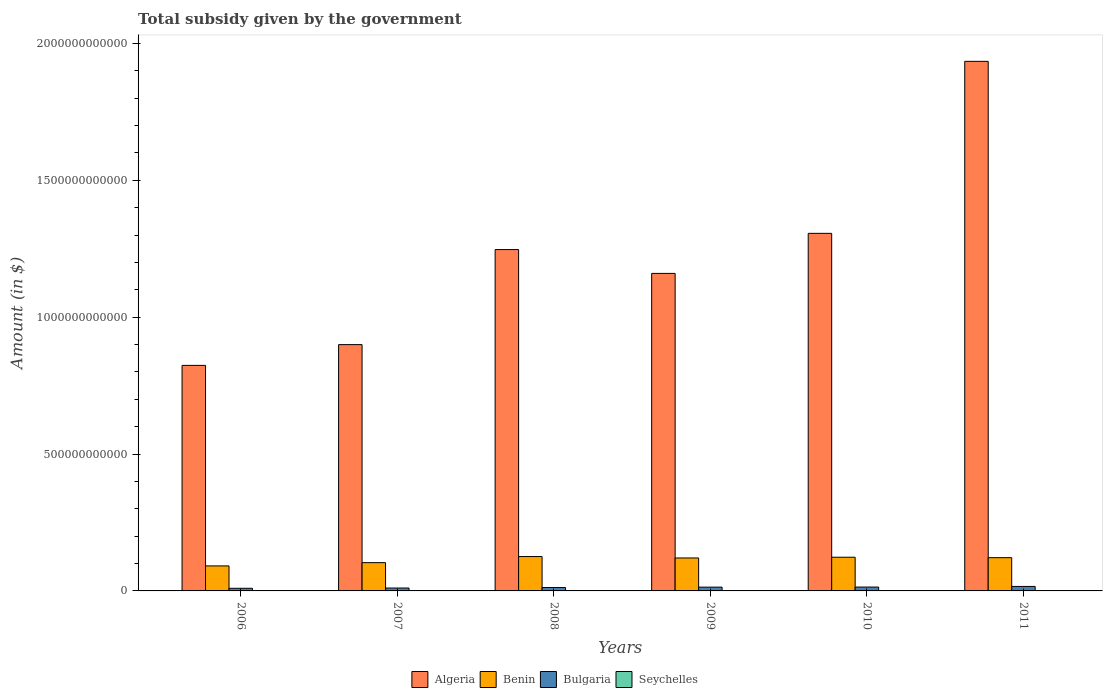How many different coloured bars are there?
Ensure brevity in your answer.  4. How many bars are there on the 1st tick from the left?
Ensure brevity in your answer.  4. How many bars are there on the 3rd tick from the right?
Ensure brevity in your answer.  4. What is the label of the 1st group of bars from the left?
Your response must be concise. 2006. What is the total revenue collected by the government in Seychelles in 2009?
Provide a short and direct response. 5.37e+08. Across all years, what is the maximum total revenue collected by the government in Algeria?
Give a very brief answer. 1.93e+12. Across all years, what is the minimum total revenue collected by the government in Bulgaria?
Offer a terse response. 9.61e+09. In which year was the total revenue collected by the government in Bulgaria maximum?
Your answer should be very brief. 2011. In which year was the total revenue collected by the government in Algeria minimum?
Make the answer very short. 2006. What is the total total revenue collected by the government in Seychelles in the graph?
Your answer should be very brief. 3.62e+09. What is the difference between the total revenue collected by the government in Seychelles in 2007 and that in 2009?
Make the answer very short. 1.41e+08. What is the difference between the total revenue collected by the government in Algeria in 2007 and the total revenue collected by the government in Benin in 2006?
Your answer should be very brief. 8.08e+11. What is the average total revenue collected by the government in Benin per year?
Keep it short and to the point. 1.14e+11. In the year 2011, what is the difference between the total revenue collected by the government in Benin and total revenue collected by the government in Bulgaria?
Provide a short and direct response. 1.05e+11. In how many years, is the total revenue collected by the government in Algeria greater than 1700000000000 $?
Keep it short and to the point. 1. What is the ratio of the total revenue collected by the government in Seychelles in 2007 to that in 2009?
Make the answer very short. 1.26. What is the difference between the highest and the second highest total revenue collected by the government in Benin?
Provide a short and direct response. 2.43e+09. What is the difference between the highest and the lowest total revenue collected by the government in Bulgaria?
Your answer should be very brief. 6.74e+09. In how many years, is the total revenue collected by the government in Algeria greater than the average total revenue collected by the government in Algeria taken over all years?
Ensure brevity in your answer.  3. Is it the case that in every year, the sum of the total revenue collected by the government in Seychelles and total revenue collected by the government in Benin is greater than the sum of total revenue collected by the government in Algeria and total revenue collected by the government in Bulgaria?
Provide a succinct answer. Yes. What does the 3rd bar from the left in 2011 represents?
Give a very brief answer. Bulgaria. What does the 2nd bar from the right in 2009 represents?
Keep it short and to the point. Bulgaria. How many bars are there?
Offer a very short reply. 24. Are all the bars in the graph horizontal?
Keep it short and to the point. No. What is the difference between two consecutive major ticks on the Y-axis?
Your response must be concise. 5.00e+11. Does the graph contain any zero values?
Ensure brevity in your answer.  No. Where does the legend appear in the graph?
Your answer should be very brief. Bottom center. How are the legend labels stacked?
Ensure brevity in your answer.  Horizontal. What is the title of the graph?
Your response must be concise. Total subsidy given by the government. What is the label or title of the Y-axis?
Give a very brief answer. Amount (in $). What is the Amount (in $) of Algeria in 2006?
Provide a succinct answer. 8.24e+11. What is the Amount (in $) in Benin in 2006?
Keep it short and to the point. 9.14e+1. What is the Amount (in $) in Bulgaria in 2006?
Ensure brevity in your answer.  9.61e+09. What is the Amount (in $) of Seychelles in 2006?
Make the answer very short. 5.37e+08. What is the Amount (in $) of Algeria in 2007?
Provide a short and direct response. 9.00e+11. What is the Amount (in $) of Benin in 2007?
Your answer should be very brief. 1.03e+11. What is the Amount (in $) in Bulgaria in 2007?
Your answer should be compact. 1.06e+1. What is the Amount (in $) of Seychelles in 2007?
Keep it short and to the point. 6.78e+08. What is the Amount (in $) in Algeria in 2008?
Your response must be concise. 1.25e+12. What is the Amount (in $) in Benin in 2008?
Offer a terse response. 1.26e+11. What is the Amount (in $) in Bulgaria in 2008?
Give a very brief answer. 1.24e+1. What is the Amount (in $) in Seychelles in 2008?
Provide a succinct answer. 6.32e+08. What is the Amount (in $) of Algeria in 2009?
Ensure brevity in your answer.  1.16e+12. What is the Amount (in $) in Benin in 2009?
Offer a very short reply. 1.20e+11. What is the Amount (in $) in Bulgaria in 2009?
Provide a succinct answer. 1.39e+1. What is the Amount (in $) in Seychelles in 2009?
Provide a short and direct response. 5.37e+08. What is the Amount (in $) in Algeria in 2010?
Offer a terse response. 1.31e+12. What is the Amount (in $) of Benin in 2010?
Give a very brief answer. 1.23e+11. What is the Amount (in $) in Bulgaria in 2010?
Provide a short and direct response. 1.41e+1. What is the Amount (in $) of Seychelles in 2010?
Ensure brevity in your answer.  7.44e+08. What is the Amount (in $) of Algeria in 2011?
Give a very brief answer. 1.93e+12. What is the Amount (in $) of Benin in 2011?
Provide a succinct answer. 1.22e+11. What is the Amount (in $) of Bulgaria in 2011?
Make the answer very short. 1.63e+1. What is the Amount (in $) of Seychelles in 2011?
Ensure brevity in your answer.  4.94e+08. Across all years, what is the maximum Amount (in $) of Algeria?
Offer a very short reply. 1.93e+12. Across all years, what is the maximum Amount (in $) of Benin?
Your answer should be very brief. 1.26e+11. Across all years, what is the maximum Amount (in $) in Bulgaria?
Ensure brevity in your answer.  1.63e+1. Across all years, what is the maximum Amount (in $) in Seychelles?
Offer a terse response. 7.44e+08. Across all years, what is the minimum Amount (in $) in Algeria?
Provide a succinct answer. 8.24e+11. Across all years, what is the minimum Amount (in $) in Benin?
Ensure brevity in your answer.  9.14e+1. Across all years, what is the minimum Amount (in $) of Bulgaria?
Provide a succinct answer. 9.61e+09. Across all years, what is the minimum Amount (in $) in Seychelles?
Your answer should be very brief. 4.94e+08. What is the total Amount (in $) in Algeria in the graph?
Keep it short and to the point. 7.37e+12. What is the total Amount (in $) in Benin in the graph?
Provide a short and direct response. 6.85e+11. What is the total Amount (in $) of Bulgaria in the graph?
Provide a succinct answer. 7.69e+1. What is the total Amount (in $) in Seychelles in the graph?
Offer a very short reply. 3.62e+09. What is the difference between the Amount (in $) of Algeria in 2006 and that in 2007?
Your answer should be very brief. -7.58e+1. What is the difference between the Amount (in $) of Benin in 2006 and that in 2007?
Make the answer very short. -1.19e+1. What is the difference between the Amount (in $) of Bulgaria in 2006 and that in 2007?
Your answer should be very brief. -9.55e+08. What is the difference between the Amount (in $) in Seychelles in 2006 and that in 2007?
Your response must be concise. -1.41e+08. What is the difference between the Amount (in $) of Algeria in 2006 and that in 2008?
Ensure brevity in your answer.  -4.23e+11. What is the difference between the Amount (in $) of Benin in 2006 and that in 2008?
Make the answer very short. -3.42e+1. What is the difference between the Amount (in $) of Bulgaria in 2006 and that in 2008?
Provide a short and direct response. -2.77e+09. What is the difference between the Amount (in $) of Seychelles in 2006 and that in 2008?
Your answer should be compact. -9.57e+07. What is the difference between the Amount (in $) in Algeria in 2006 and that in 2009?
Your answer should be compact. -3.36e+11. What is the difference between the Amount (in $) of Benin in 2006 and that in 2009?
Provide a short and direct response. -2.91e+1. What is the difference between the Amount (in $) in Bulgaria in 2006 and that in 2009?
Make the answer very short. -4.25e+09. What is the difference between the Amount (in $) of Seychelles in 2006 and that in 2009?
Give a very brief answer. -7.73e+05. What is the difference between the Amount (in $) of Algeria in 2006 and that in 2010?
Your answer should be very brief. -4.82e+11. What is the difference between the Amount (in $) of Benin in 2006 and that in 2010?
Your answer should be compact. -3.17e+1. What is the difference between the Amount (in $) in Bulgaria in 2006 and that in 2010?
Keep it short and to the point. -4.49e+09. What is the difference between the Amount (in $) in Seychelles in 2006 and that in 2010?
Keep it short and to the point. -2.07e+08. What is the difference between the Amount (in $) in Algeria in 2006 and that in 2011?
Provide a short and direct response. -1.11e+12. What is the difference between the Amount (in $) of Benin in 2006 and that in 2011?
Make the answer very short. -3.02e+1. What is the difference between the Amount (in $) of Bulgaria in 2006 and that in 2011?
Offer a terse response. -6.74e+09. What is the difference between the Amount (in $) of Seychelles in 2006 and that in 2011?
Offer a terse response. 4.30e+07. What is the difference between the Amount (in $) in Algeria in 2007 and that in 2008?
Offer a terse response. -3.47e+11. What is the difference between the Amount (in $) of Benin in 2007 and that in 2008?
Make the answer very short. -2.23e+1. What is the difference between the Amount (in $) of Bulgaria in 2007 and that in 2008?
Ensure brevity in your answer.  -1.82e+09. What is the difference between the Amount (in $) of Seychelles in 2007 and that in 2008?
Offer a very short reply. 4.56e+07. What is the difference between the Amount (in $) in Algeria in 2007 and that in 2009?
Your answer should be compact. -2.60e+11. What is the difference between the Amount (in $) of Benin in 2007 and that in 2009?
Offer a very short reply. -1.71e+1. What is the difference between the Amount (in $) in Bulgaria in 2007 and that in 2009?
Provide a short and direct response. -3.30e+09. What is the difference between the Amount (in $) in Seychelles in 2007 and that in 2009?
Your response must be concise. 1.41e+08. What is the difference between the Amount (in $) of Algeria in 2007 and that in 2010?
Your response must be concise. -4.06e+11. What is the difference between the Amount (in $) in Benin in 2007 and that in 2010?
Make the answer very short. -1.98e+1. What is the difference between the Amount (in $) of Bulgaria in 2007 and that in 2010?
Make the answer very short. -3.54e+09. What is the difference between the Amount (in $) in Seychelles in 2007 and that in 2010?
Your answer should be very brief. -6.58e+07. What is the difference between the Amount (in $) in Algeria in 2007 and that in 2011?
Offer a very short reply. -1.03e+12. What is the difference between the Amount (in $) in Benin in 2007 and that in 2011?
Provide a short and direct response. -1.83e+1. What is the difference between the Amount (in $) of Bulgaria in 2007 and that in 2011?
Give a very brief answer. -5.78e+09. What is the difference between the Amount (in $) in Seychelles in 2007 and that in 2011?
Make the answer very short. 1.84e+08. What is the difference between the Amount (in $) of Algeria in 2008 and that in 2009?
Provide a succinct answer. 8.71e+1. What is the difference between the Amount (in $) of Benin in 2008 and that in 2009?
Your response must be concise. 5.12e+09. What is the difference between the Amount (in $) of Bulgaria in 2008 and that in 2009?
Keep it short and to the point. -1.48e+09. What is the difference between the Amount (in $) of Seychelles in 2008 and that in 2009?
Ensure brevity in your answer.  9.50e+07. What is the difference between the Amount (in $) in Algeria in 2008 and that in 2010?
Keep it short and to the point. -5.92e+1. What is the difference between the Amount (in $) of Benin in 2008 and that in 2010?
Provide a short and direct response. 2.43e+09. What is the difference between the Amount (in $) in Bulgaria in 2008 and that in 2010?
Your response must be concise. -1.72e+09. What is the difference between the Amount (in $) in Seychelles in 2008 and that in 2010?
Your response must be concise. -1.11e+08. What is the difference between the Amount (in $) of Algeria in 2008 and that in 2011?
Make the answer very short. -6.88e+11. What is the difference between the Amount (in $) in Benin in 2008 and that in 2011?
Give a very brief answer. 4.01e+09. What is the difference between the Amount (in $) of Bulgaria in 2008 and that in 2011?
Provide a succinct answer. -3.96e+09. What is the difference between the Amount (in $) of Seychelles in 2008 and that in 2011?
Offer a very short reply. 1.39e+08. What is the difference between the Amount (in $) of Algeria in 2009 and that in 2010?
Provide a short and direct response. -1.46e+11. What is the difference between the Amount (in $) in Benin in 2009 and that in 2010?
Ensure brevity in your answer.  -2.69e+09. What is the difference between the Amount (in $) of Bulgaria in 2009 and that in 2010?
Keep it short and to the point. -2.37e+08. What is the difference between the Amount (in $) in Seychelles in 2009 and that in 2010?
Your response must be concise. -2.06e+08. What is the difference between the Amount (in $) in Algeria in 2009 and that in 2011?
Your response must be concise. -7.75e+11. What is the difference between the Amount (in $) of Benin in 2009 and that in 2011?
Provide a succinct answer. -1.11e+09. What is the difference between the Amount (in $) in Bulgaria in 2009 and that in 2011?
Ensure brevity in your answer.  -2.48e+09. What is the difference between the Amount (in $) in Seychelles in 2009 and that in 2011?
Give a very brief answer. 4.37e+07. What is the difference between the Amount (in $) in Algeria in 2010 and that in 2011?
Your response must be concise. -6.28e+11. What is the difference between the Amount (in $) of Benin in 2010 and that in 2011?
Your response must be concise. 1.58e+09. What is the difference between the Amount (in $) of Bulgaria in 2010 and that in 2011?
Ensure brevity in your answer.  -2.24e+09. What is the difference between the Amount (in $) in Seychelles in 2010 and that in 2011?
Give a very brief answer. 2.50e+08. What is the difference between the Amount (in $) of Algeria in 2006 and the Amount (in $) of Benin in 2007?
Provide a short and direct response. 7.21e+11. What is the difference between the Amount (in $) in Algeria in 2006 and the Amount (in $) in Bulgaria in 2007?
Your answer should be very brief. 8.13e+11. What is the difference between the Amount (in $) of Algeria in 2006 and the Amount (in $) of Seychelles in 2007?
Your response must be concise. 8.23e+11. What is the difference between the Amount (in $) of Benin in 2006 and the Amount (in $) of Bulgaria in 2007?
Your response must be concise. 8.08e+1. What is the difference between the Amount (in $) in Benin in 2006 and the Amount (in $) in Seychelles in 2007?
Keep it short and to the point. 9.07e+1. What is the difference between the Amount (in $) of Bulgaria in 2006 and the Amount (in $) of Seychelles in 2007?
Make the answer very short. 8.94e+09. What is the difference between the Amount (in $) in Algeria in 2006 and the Amount (in $) in Benin in 2008?
Ensure brevity in your answer.  6.98e+11. What is the difference between the Amount (in $) in Algeria in 2006 and the Amount (in $) in Bulgaria in 2008?
Keep it short and to the point. 8.12e+11. What is the difference between the Amount (in $) of Algeria in 2006 and the Amount (in $) of Seychelles in 2008?
Give a very brief answer. 8.23e+11. What is the difference between the Amount (in $) of Benin in 2006 and the Amount (in $) of Bulgaria in 2008?
Make the answer very short. 7.90e+1. What is the difference between the Amount (in $) in Benin in 2006 and the Amount (in $) in Seychelles in 2008?
Provide a succinct answer. 9.07e+1. What is the difference between the Amount (in $) of Bulgaria in 2006 and the Amount (in $) of Seychelles in 2008?
Offer a very short reply. 8.98e+09. What is the difference between the Amount (in $) of Algeria in 2006 and the Amount (in $) of Benin in 2009?
Keep it short and to the point. 7.04e+11. What is the difference between the Amount (in $) of Algeria in 2006 and the Amount (in $) of Bulgaria in 2009?
Offer a terse response. 8.10e+11. What is the difference between the Amount (in $) in Algeria in 2006 and the Amount (in $) in Seychelles in 2009?
Your response must be concise. 8.23e+11. What is the difference between the Amount (in $) in Benin in 2006 and the Amount (in $) in Bulgaria in 2009?
Provide a succinct answer. 7.75e+1. What is the difference between the Amount (in $) in Benin in 2006 and the Amount (in $) in Seychelles in 2009?
Provide a short and direct response. 9.08e+1. What is the difference between the Amount (in $) of Bulgaria in 2006 and the Amount (in $) of Seychelles in 2009?
Ensure brevity in your answer.  9.08e+09. What is the difference between the Amount (in $) in Algeria in 2006 and the Amount (in $) in Benin in 2010?
Your response must be concise. 7.01e+11. What is the difference between the Amount (in $) in Algeria in 2006 and the Amount (in $) in Bulgaria in 2010?
Your answer should be very brief. 8.10e+11. What is the difference between the Amount (in $) in Algeria in 2006 and the Amount (in $) in Seychelles in 2010?
Ensure brevity in your answer.  8.23e+11. What is the difference between the Amount (in $) in Benin in 2006 and the Amount (in $) in Bulgaria in 2010?
Provide a succinct answer. 7.73e+1. What is the difference between the Amount (in $) in Benin in 2006 and the Amount (in $) in Seychelles in 2010?
Offer a terse response. 9.06e+1. What is the difference between the Amount (in $) of Bulgaria in 2006 and the Amount (in $) of Seychelles in 2010?
Your answer should be compact. 8.87e+09. What is the difference between the Amount (in $) of Algeria in 2006 and the Amount (in $) of Benin in 2011?
Your response must be concise. 7.02e+11. What is the difference between the Amount (in $) of Algeria in 2006 and the Amount (in $) of Bulgaria in 2011?
Your answer should be compact. 8.08e+11. What is the difference between the Amount (in $) in Algeria in 2006 and the Amount (in $) in Seychelles in 2011?
Your answer should be very brief. 8.23e+11. What is the difference between the Amount (in $) of Benin in 2006 and the Amount (in $) of Bulgaria in 2011?
Offer a terse response. 7.50e+1. What is the difference between the Amount (in $) in Benin in 2006 and the Amount (in $) in Seychelles in 2011?
Make the answer very short. 9.09e+1. What is the difference between the Amount (in $) in Bulgaria in 2006 and the Amount (in $) in Seychelles in 2011?
Your answer should be very brief. 9.12e+09. What is the difference between the Amount (in $) of Algeria in 2007 and the Amount (in $) of Benin in 2008?
Offer a very short reply. 7.74e+11. What is the difference between the Amount (in $) of Algeria in 2007 and the Amount (in $) of Bulgaria in 2008?
Provide a succinct answer. 8.87e+11. What is the difference between the Amount (in $) in Algeria in 2007 and the Amount (in $) in Seychelles in 2008?
Ensure brevity in your answer.  8.99e+11. What is the difference between the Amount (in $) in Benin in 2007 and the Amount (in $) in Bulgaria in 2008?
Your answer should be very brief. 9.09e+1. What is the difference between the Amount (in $) in Benin in 2007 and the Amount (in $) in Seychelles in 2008?
Offer a very short reply. 1.03e+11. What is the difference between the Amount (in $) in Bulgaria in 2007 and the Amount (in $) in Seychelles in 2008?
Give a very brief answer. 9.94e+09. What is the difference between the Amount (in $) in Algeria in 2007 and the Amount (in $) in Benin in 2009?
Offer a terse response. 7.79e+11. What is the difference between the Amount (in $) in Algeria in 2007 and the Amount (in $) in Bulgaria in 2009?
Ensure brevity in your answer.  8.86e+11. What is the difference between the Amount (in $) of Algeria in 2007 and the Amount (in $) of Seychelles in 2009?
Offer a very short reply. 8.99e+11. What is the difference between the Amount (in $) of Benin in 2007 and the Amount (in $) of Bulgaria in 2009?
Provide a succinct answer. 8.94e+1. What is the difference between the Amount (in $) in Benin in 2007 and the Amount (in $) in Seychelles in 2009?
Keep it short and to the point. 1.03e+11. What is the difference between the Amount (in $) in Bulgaria in 2007 and the Amount (in $) in Seychelles in 2009?
Make the answer very short. 1.00e+1. What is the difference between the Amount (in $) in Algeria in 2007 and the Amount (in $) in Benin in 2010?
Provide a succinct answer. 7.77e+11. What is the difference between the Amount (in $) in Algeria in 2007 and the Amount (in $) in Bulgaria in 2010?
Make the answer very short. 8.86e+11. What is the difference between the Amount (in $) of Algeria in 2007 and the Amount (in $) of Seychelles in 2010?
Your answer should be very brief. 8.99e+11. What is the difference between the Amount (in $) of Benin in 2007 and the Amount (in $) of Bulgaria in 2010?
Provide a short and direct response. 8.92e+1. What is the difference between the Amount (in $) of Benin in 2007 and the Amount (in $) of Seychelles in 2010?
Your response must be concise. 1.03e+11. What is the difference between the Amount (in $) of Bulgaria in 2007 and the Amount (in $) of Seychelles in 2010?
Provide a short and direct response. 9.83e+09. What is the difference between the Amount (in $) in Algeria in 2007 and the Amount (in $) in Benin in 2011?
Your answer should be very brief. 7.78e+11. What is the difference between the Amount (in $) in Algeria in 2007 and the Amount (in $) in Bulgaria in 2011?
Provide a short and direct response. 8.83e+11. What is the difference between the Amount (in $) of Algeria in 2007 and the Amount (in $) of Seychelles in 2011?
Offer a terse response. 8.99e+11. What is the difference between the Amount (in $) in Benin in 2007 and the Amount (in $) in Bulgaria in 2011?
Your response must be concise. 8.69e+1. What is the difference between the Amount (in $) in Benin in 2007 and the Amount (in $) in Seychelles in 2011?
Provide a succinct answer. 1.03e+11. What is the difference between the Amount (in $) of Bulgaria in 2007 and the Amount (in $) of Seychelles in 2011?
Your response must be concise. 1.01e+1. What is the difference between the Amount (in $) of Algeria in 2008 and the Amount (in $) of Benin in 2009?
Your response must be concise. 1.13e+12. What is the difference between the Amount (in $) of Algeria in 2008 and the Amount (in $) of Bulgaria in 2009?
Give a very brief answer. 1.23e+12. What is the difference between the Amount (in $) in Algeria in 2008 and the Amount (in $) in Seychelles in 2009?
Provide a succinct answer. 1.25e+12. What is the difference between the Amount (in $) of Benin in 2008 and the Amount (in $) of Bulgaria in 2009?
Make the answer very short. 1.12e+11. What is the difference between the Amount (in $) of Benin in 2008 and the Amount (in $) of Seychelles in 2009?
Ensure brevity in your answer.  1.25e+11. What is the difference between the Amount (in $) of Bulgaria in 2008 and the Amount (in $) of Seychelles in 2009?
Ensure brevity in your answer.  1.18e+1. What is the difference between the Amount (in $) of Algeria in 2008 and the Amount (in $) of Benin in 2010?
Keep it short and to the point. 1.12e+12. What is the difference between the Amount (in $) of Algeria in 2008 and the Amount (in $) of Bulgaria in 2010?
Keep it short and to the point. 1.23e+12. What is the difference between the Amount (in $) in Algeria in 2008 and the Amount (in $) in Seychelles in 2010?
Give a very brief answer. 1.25e+12. What is the difference between the Amount (in $) in Benin in 2008 and the Amount (in $) in Bulgaria in 2010?
Offer a very short reply. 1.11e+11. What is the difference between the Amount (in $) of Benin in 2008 and the Amount (in $) of Seychelles in 2010?
Offer a terse response. 1.25e+11. What is the difference between the Amount (in $) of Bulgaria in 2008 and the Amount (in $) of Seychelles in 2010?
Provide a short and direct response. 1.16e+1. What is the difference between the Amount (in $) in Algeria in 2008 and the Amount (in $) in Benin in 2011?
Provide a succinct answer. 1.13e+12. What is the difference between the Amount (in $) of Algeria in 2008 and the Amount (in $) of Bulgaria in 2011?
Provide a succinct answer. 1.23e+12. What is the difference between the Amount (in $) in Algeria in 2008 and the Amount (in $) in Seychelles in 2011?
Offer a very short reply. 1.25e+12. What is the difference between the Amount (in $) of Benin in 2008 and the Amount (in $) of Bulgaria in 2011?
Your answer should be very brief. 1.09e+11. What is the difference between the Amount (in $) of Benin in 2008 and the Amount (in $) of Seychelles in 2011?
Provide a succinct answer. 1.25e+11. What is the difference between the Amount (in $) of Bulgaria in 2008 and the Amount (in $) of Seychelles in 2011?
Give a very brief answer. 1.19e+1. What is the difference between the Amount (in $) in Algeria in 2009 and the Amount (in $) in Benin in 2010?
Provide a succinct answer. 1.04e+12. What is the difference between the Amount (in $) in Algeria in 2009 and the Amount (in $) in Bulgaria in 2010?
Your answer should be compact. 1.15e+12. What is the difference between the Amount (in $) in Algeria in 2009 and the Amount (in $) in Seychelles in 2010?
Offer a very short reply. 1.16e+12. What is the difference between the Amount (in $) of Benin in 2009 and the Amount (in $) of Bulgaria in 2010?
Provide a succinct answer. 1.06e+11. What is the difference between the Amount (in $) of Benin in 2009 and the Amount (in $) of Seychelles in 2010?
Your answer should be compact. 1.20e+11. What is the difference between the Amount (in $) in Bulgaria in 2009 and the Amount (in $) in Seychelles in 2010?
Make the answer very short. 1.31e+1. What is the difference between the Amount (in $) of Algeria in 2009 and the Amount (in $) of Benin in 2011?
Offer a terse response. 1.04e+12. What is the difference between the Amount (in $) in Algeria in 2009 and the Amount (in $) in Bulgaria in 2011?
Make the answer very short. 1.14e+12. What is the difference between the Amount (in $) in Algeria in 2009 and the Amount (in $) in Seychelles in 2011?
Give a very brief answer. 1.16e+12. What is the difference between the Amount (in $) of Benin in 2009 and the Amount (in $) of Bulgaria in 2011?
Your answer should be compact. 1.04e+11. What is the difference between the Amount (in $) in Benin in 2009 and the Amount (in $) in Seychelles in 2011?
Your answer should be compact. 1.20e+11. What is the difference between the Amount (in $) of Bulgaria in 2009 and the Amount (in $) of Seychelles in 2011?
Provide a short and direct response. 1.34e+1. What is the difference between the Amount (in $) in Algeria in 2010 and the Amount (in $) in Benin in 2011?
Provide a short and direct response. 1.18e+12. What is the difference between the Amount (in $) of Algeria in 2010 and the Amount (in $) of Bulgaria in 2011?
Your response must be concise. 1.29e+12. What is the difference between the Amount (in $) in Algeria in 2010 and the Amount (in $) in Seychelles in 2011?
Make the answer very short. 1.31e+12. What is the difference between the Amount (in $) of Benin in 2010 and the Amount (in $) of Bulgaria in 2011?
Offer a very short reply. 1.07e+11. What is the difference between the Amount (in $) in Benin in 2010 and the Amount (in $) in Seychelles in 2011?
Offer a terse response. 1.23e+11. What is the difference between the Amount (in $) in Bulgaria in 2010 and the Amount (in $) in Seychelles in 2011?
Give a very brief answer. 1.36e+1. What is the average Amount (in $) in Algeria per year?
Provide a succinct answer. 1.23e+12. What is the average Amount (in $) of Benin per year?
Provide a succinct answer. 1.14e+11. What is the average Amount (in $) of Bulgaria per year?
Offer a very short reply. 1.28e+1. What is the average Amount (in $) in Seychelles per year?
Your response must be concise. 6.04e+08. In the year 2006, what is the difference between the Amount (in $) of Algeria and Amount (in $) of Benin?
Offer a very short reply. 7.33e+11. In the year 2006, what is the difference between the Amount (in $) of Algeria and Amount (in $) of Bulgaria?
Provide a succinct answer. 8.14e+11. In the year 2006, what is the difference between the Amount (in $) in Algeria and Amount (in $) in Seychelles?
Ensure brevity in your answer.  8.23e+11. In the year 2006, what is the difference between the Amount (in $) in Benin and Amount (in $) in Bulgaria?
Offer a terse response. 8.17e+1. In the year 2006, what is the difference between the Amount (in $) of Benin and Amount (in $) of Seychelles?
Offer a terse response. 9.08e+1. In the year 2006, what is the difference between the Amount (in $) of Bulgaria and Amount (in $) of Seychelles?
Provide a succinct answer. 9.08e+09. In the year 2007, what is the difference between the Amount (in $) in Algeria and Amount (in $) in Benin?
Make the answer very short. 7.97e+11. In the year 2007, what is the difference between the Amount (in $) in Algeria and Amount (in $) in Bulgaria?
Your answer should be very brief. 8.89e+11. In the year 2007, what is the difference between the Amount (in $) of Algeria and Amount (in $) of Seychelles?
Give a very brief answer. 8.99e+11. In the year 2007, what is the difference between the Amount (in $) of Benin and Amount (in $) of Bulgaria?
Your answer should be very brief. 9.27e+1. In the year 2007, what is the difference between the Amount (in $) of Benin and Amount (in $) of Seychelles?
Ensure brevity in your answer.  1.03e+11. In the year 2007, what is the difference between the Amount (in $) of Bulgaria and Amount (in $) of Seychelles?
Your answer should be compact. 9.89e+09. In the year 2008, what is the difference between the Amount (in $) in Algeria and Amount (in $) in Benin?
Make the answer very short. 1.12e+12. In the year 2008, what is the difference between the Amount (in $) of Algeria and Amount (in $) of Bulgaria?
Ensure brevity in your answer.  1.23e+12. In the year 2008, what is the difference between the Amount (in $) in Algeria and Amount (in $) in Seychelles?
Your response must be concise. 1.25e+12. In the year 2008, what is the difference between the Amount (in $) of Benin and Amount (in $) of Bulgaria?
Your answer should be very brief. 1.13e+11. In the year 2008, what is the difference between the Amount (in $) in Benin and Amount (in $) in Seychelles?
Your answer should be compact. 1.25e+11. In the year 2008, what is the difference between the Amount (in $) in Bulgaria and Amount (in $) in Seychelles?
Provide a succinct answer. 1.18e+1. In the year 2009, what is the difference between the Amount (in $) of Algeria and Amount (in $) of Benin?
Offer a very short reply. 1.04e+12. In the year 2009, what is the difference between the Amount (in $) in Algeria and Amount (in $) in Bulgaria?
Your response must be concise. 1.15e+12. In the year 2009, what is the difference between the Amount (in $) in Algeria and Amount (in $) in Seychelles?
Give a very brief answer. 1.16e+12. In the year 2009, what is the difference between the Amount (in $) in Benin and Amount (in $) in Bulgaria?
Keep it short and to the point. 1.07e+11. In the year 2009, what is the difference between the Amount (in $) in Benin and Amount (in $) in Seychelles?
Your response must be concise. 1.20e+11. In the year 2009, what is the difference between the Amount (in $) of Bulgaria and Amount (in $) of Seychelles?
Offer a very short reply. 1.33e+1. In the year 2010, what is the difference between the Amount (in $) of Algeria and Amount (in $) of Benin?
Provide a succinct answer. 1.18e+12. In the year 2010, what is the difference between the Amount (in $) in Algeria and Amount (in $) in Bulgaria?
Keep it short and to the point. 1.29e+12. In the year 2010, what is the difference between the Amount (in $) of Algeria and Amount (in $) of Seychelles?
Your answer should be very brief. 1.31e+12. In the year 2010, what is the difference between the Amount (in $) in Benin and Amount (in $) in Bulgaria?
Offer a terse response. 1.09e+11. In the year 2010, what is the difference between the Amount (in $) in Benin and Amount (in $) in Seychelles?
Offer a very short reply. 1.22e+11. In the year 2010, what is the difference between the Amount (in $) of Bulgaria and Amount (in $) of Seychelles?
Offer a very short reply. 1.34e+1. In the year 2011, what is the difference between the Amount (in $) of Algeria and Amount (in $) of Benin?
Provide a succinct answer. 1.81e+12. In the year 2011, what is the difference between the Amount (in $) in Algeria and Amount (in $) in Bulgaria?
Ensure brevity in your answer.  1.92e+12. In the year 2011, what is the difference between the Amount (in $) of Algeria and Amount (in $) of Seychelles?
Your response must be concise. 1.93e+12. In the year 2011, what is the difference between the Amount (in $) in Benin and Amount (in $) in Bulgaria?
Keep it short and to the point. 1.05e+11. In the year 2011, what is the difference between the Amount (in $) of Benin and Amount (in $) of Seychelles?
Make the answer very short. 1.21e+11. In the year 2011, what is the difference between the Amount (in $) of Bulgaria and Amount (in $) of Seychelles?
Make the answer very short. 1.59e+1. What is the ratio of the Amount (in $) of Algeria in 2006 to that in 2007?
Offer a terse response. 0.92. What is the ratio of the Amount (in $) in Benin in 2006 to that in 2007?
Your answer should be compact. 0.88. What is the ratio of the Amount (in $) in Bulgaria in 2006 to that in 2007?
Offer a very short reply. 0.91. What is the ratio of the Amount (in $) of Seychelles in 2006 to that in 2007?
Keep it short and to the point. 0.79. What is the ratio of the Amount (in $) in Algeria in 2006 to that in 2008?
Offer a terse response. 0.66. What is the ratio of the Amount (in $) of Benin in 2006 to that in 2008?
Make the answer very short. 0.73. What is the ratio of the Amount (in $) of Bulgaria in 2006 to that in 2008?
Keep it short and to the point. 0.78. What is the ratio of the Amount (in $) in Seychelles in 2006 to that in 2008?
Your answer should be compact. 0.85. What is the ratio of the Amount (in $) of Algeria in 2006 to that in 2009?
Provide a succinct answer. 0.71. What is the ratio of the Amount (in $) in Benin in 2006 to that in 2009?
Make the answer very short. 0.76. What is the ratio of the Amount (in $) in Bulgaria in 2006 to that in 2009?
Offer a terse response. 0.69. What is the ratio of the Amount (in $) of Seychelles in 2006 to that in 2009?
Your answer should be very brief. 1. What is the ratio of the Amount (in $) in Algeria in 2006 to that in 2010?
Your answer should be compact. 0.63. What is the ratio of the Amount (in $) of Benin in 2006 to that in 2010?
Provide a succinct answer. 0.74. What is the ratio of the Amount (in $) of Bulgaria in 2006 to that in 2010?
Provide a short and direct response. 0.68. What is the ratio of the Amount (in $) in Seychelles in 2006 to that in 2010?
Ensure brevity in your answer.  0.72. What is the ratio of the Amount (in $) in Algeria in 2006 to that in 2011?
Your answer should be compact. 0.43. What is the ratio of the Amount (in $) in Benin in 2006 to that in 2011?
Make the answer very short. 0.75. What is the ratio of the Amount (in $) in Bulgaria in 2006 to that in 2011?
Make the answer very short. 0.59. What is the ratio of the Amount (in $) of Seychelles in 2006 to that in 2011?
Your answer should be very brief. 1.09. What is the ratio of the Amount (in $) in Algeria in 2007 to that in 2008?
Your answer should be compact. 0.72. What is the ratio of the Amount (in $) in Benin in 2007 to that in 2008?
Your answer should be very brief. 0.82. What is the ratio of the Amount (in $) in Bulgaria in 2007 to that in 2008?
Offer a terse response. 0.85. What is the ratio of the Amount (in $) in Seychelles in 2007 to that in 2008?
Offer a very short reply. 1.07. What is the ratio of the Amount (in $) of Algeria in 2007 to that in 2009?
Ensure brevity in your answer.  0.78. What is the ratio of the Amount (in $) in Benin in 2007 to that in 2009?
Offer a very short reply. 0.86. What is the ratio of the Amount (in $) of Bulgaria in 2007 to that in 2009?
Your response must be concise. 0.76. What is the ratio of the Amount (in $) of Seychelles in 2007 to that in 2009?
Provide a succinct answer. 1.26. What is the ratio of the Amount (in $) in Algeria in 2007 to that in 2010?
Provide a succinct answer. 0.69. What is the ratio of the Amount (in $) in Benin in 2007 to that in 2010?
Your answer should be very brief. 0.84. What is the ratio of the Amount (in $) in Bulgaria in 2007 to that in 2010?
Provide a short and direct response. 0.75. What is the ratio of the Amount (in $) of Seychelles in 2007 to that in 2010?
Offer a terse response. 0.91. What is the ratio of the Amount (in $) of Algeria in 2007 to that in 2011?
Offer a terse response. 0.47. What is the ratio of the Amount (in $) of Benin in 2007 to that in 2011?
Your answer should be compact. 0.85. What is the ratio of the Amount (in $) in Bulgaria in 2007 to that in 2011?
Offer a very short reply. 0.65. What is the ratio of the Amount (in $) of Seychelles in 2007 to that in 2011?
Provide a short and direct response. 1.37. What is the ratio of the Amount (in $) in Algeria in 2008 to that in 2009?
Offer a terse response. 1.08. What is the ratio of the Amount (in $) of Benin in 2008 to that in 2009?
Your response must be concise. 1.04. What is the ratio of the Amount (in $) of Bulgaria in 2008 to that in 2009?
Provide a succinct answer. 0.89. What is the ratio of the Amount (in $) of Seychelles in 2008 to that in 2009?
Ensure brevity in your answer.  1.18. What is the ratio of the Amount (in $) of Algeria in 2008 to that in 2010?
Offer a terse response. 0.95. What is the ratio of the Amount (in $) in Benin in 2008 to that in 2010?
Make the answer very short. 1.02. What is the ratio of the Amount (in $) in Bulgaria in 2008 to that in 2010?
Your answer should be compact. 0.88. What is the ratio of the Amount (in $) of Seychelles in 2008 to that in 2010?
Your response must be concise. 0.85. What is the ratio of the Amount (in $) in Algeria in 2008 to that in 2011?
Your answer should be compact. 0.64. What is the ratio of the Amount (in $) in Benin in 2008 to that in 2011?
Your answer should be very brief. 1.03. What is the ratio of the Amount (in $) in Bulgaria in 2008 to that in 2011?
Provide a short and direct response. 0.76. What is the ratio of the Amount (in $) in Seychelles in 2008 to that in 2011?
Offer a terse response. 1.28. What is the ratio of the Amount (in $) in Algeria in 2009 to that in 2010?
Provide a succinct answer. 0.89. What is the ratio of the Amount (in $) of Benin in 2009 to that in 2010?
Ensure brevity in your answer.  0.98. What is the ratio of the Amount (in $) of Bulgaria in 2009 to that in 2010?
Offer a very short reply. 0.98. What is the ratio of the Amount (in $) in Seychelles in 2009 to that in 2010?
Your answer should be compact. 0.72. What is the ratio of the Amount (in $) of Algeria in 2009 to that in 2011?
Your answer should be very brief. 0.6. What is the ratio of the Amount (in $) in Benin in 2009 to that in 2011?
Your response must be concise. 0.99. What is the ratio of the Amount (in $) of Bulgaria in 2009 to that in 2011?
Your response must be concise. 0.85. What is the ratio of the Amount (in $) of Seychelles in 2009 to that in 2011?
Keep it short and to the point. 1.09. What is the ratio of the Amount (in $) of Algeria in 2010 to that in 2011?
Keep it short and to the point. 0.68. What is the ratio of the Amount (in $) in Benin in 2010 to that in 2011?
Give a very brief answer. 1.01. What is the ratio of the Amount (in $) of Bulgaria in 2010 to that in 2011?
Ensure brevity in your answer.  0.86. What is the ratio of the Amount (in $) in Seychelles in 2010 to that in 2011?
Offer a very short reply. 1.51. What is the difference between the highest and the second highest Amount (in $) in Algeria?
Provide a short and direct response. 6.28e+11. What is the difference between the highest and the second highest Amount (in $) in Benin?
Provide a succinct answer. 2.43e+09. What is the difference between the highest and the second highest Amount (in $) of Bulgaria?
Offer a terse response. 2.24e+09. What is the difference between the highest and the second highest Amount (in $) in Seychelles?
Offer a very short reply. 6.58e+07. What is the difference between the highest and the lowest Amount (in $) of Algeria?
Your response must be concise. 1.11e+12. What is the difference between the highest and the lowest Amount (in $) in Benin?
Offer a very short reply. 3.42e+1. What is the difference between the highest and the lowest Amount (in $) of Bulgaria?
Your answer should be compact. 6.74e+09. What is the difference between the highest and the lowest Amount (in $) of Seychelles?
Offer a very short reply. 2.50e+08. 